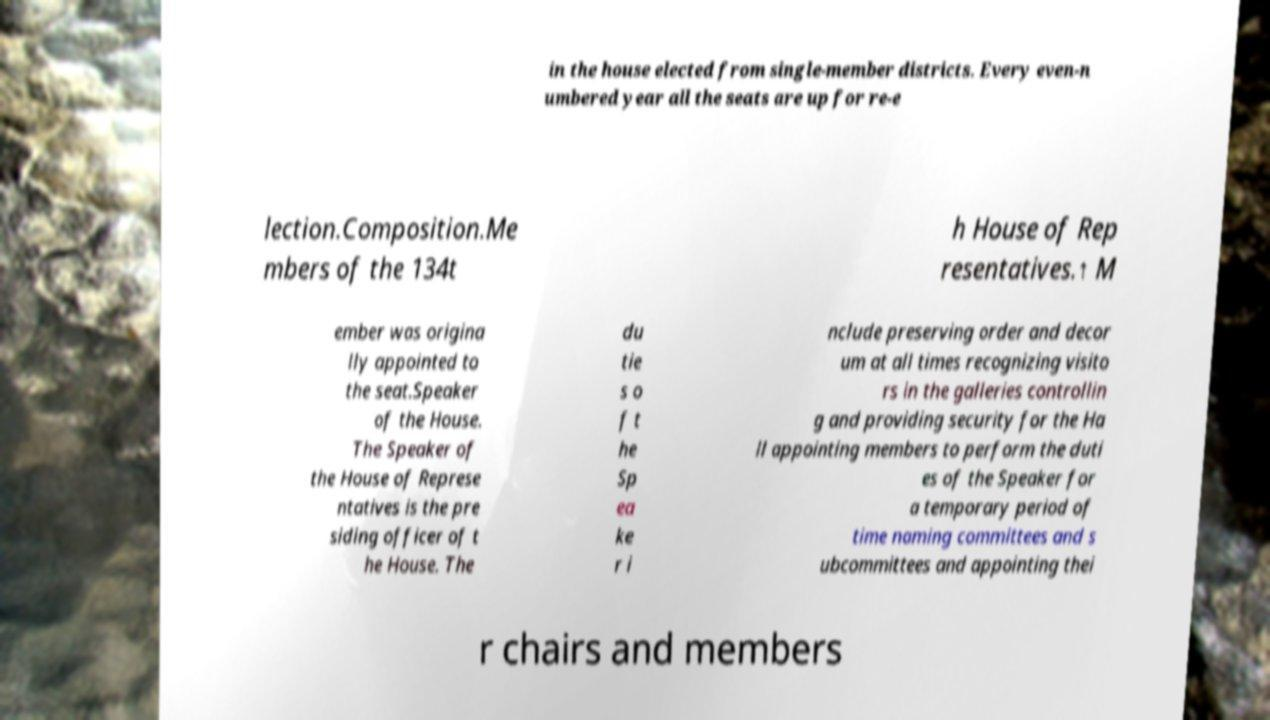I need the written content from this picture converted into text. Can you do that? in the house elected from single-member districts. Every even-n umbered year all the seats are up for re-e lection.Composition.Me mbers of the 134t h House of Rep resentatives.↑ M ember was origina lly appointed to the seat.Speaker of the House. The Speaker of the House of Represe ntatives is the pre siding officer of t he House. The du tie s o f t he Sp ea ke r i nclude preserving order and decor um at all times recognizing visito rs in the galleries controllin g and providing security for the Ha ll appointing members to perform the duti es of the Speaker for a temporary period of time naming committees and s ubcommittees and appointing thei r chairs and members 